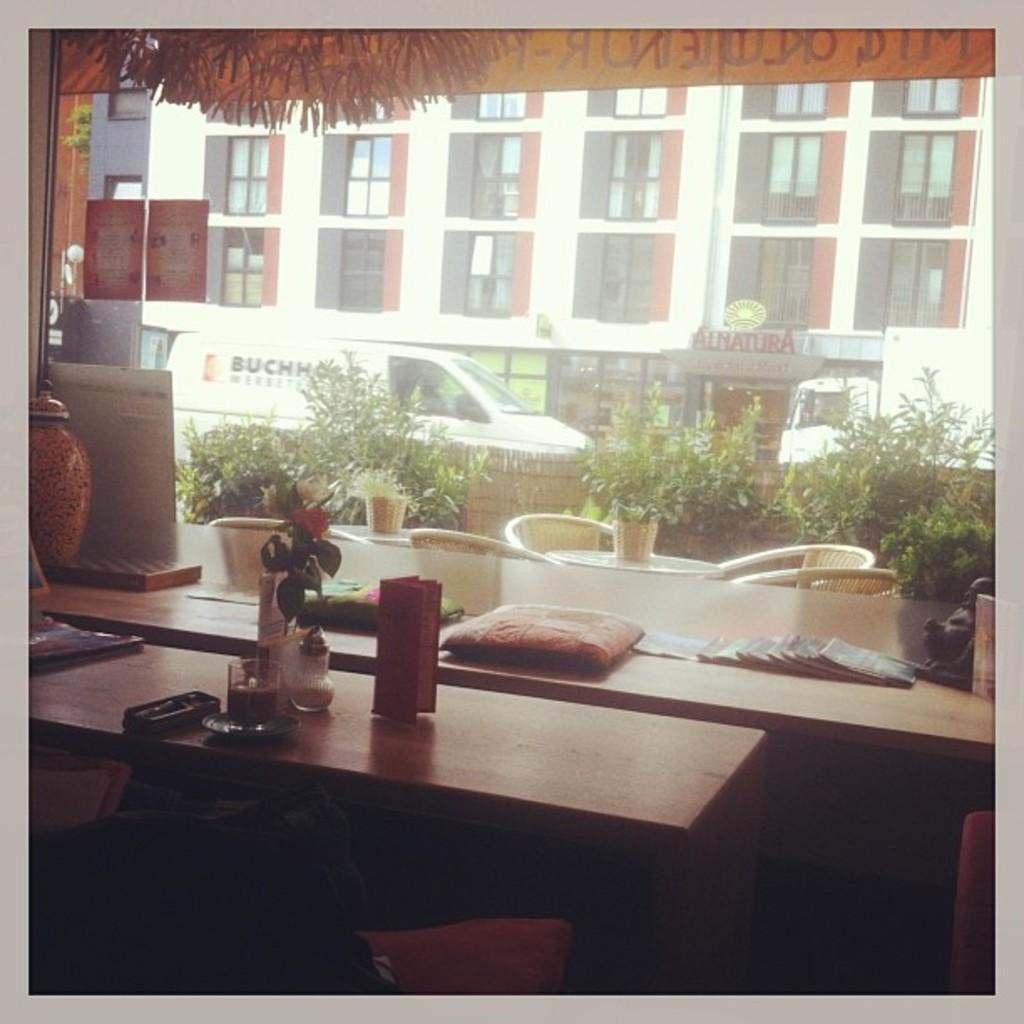In one or two sentences, can you explain what this image depicts? In the center of the image we can see tables, books, saucer, plant, glass and some objects. At the bottom left side of the image, we can see some objects. At the bottom right side of the image, we can see one object. Through the glass, we can see one building, windows, vehicles, chairs, tables, pots and plants. On the glass, we can see some text and posters. 